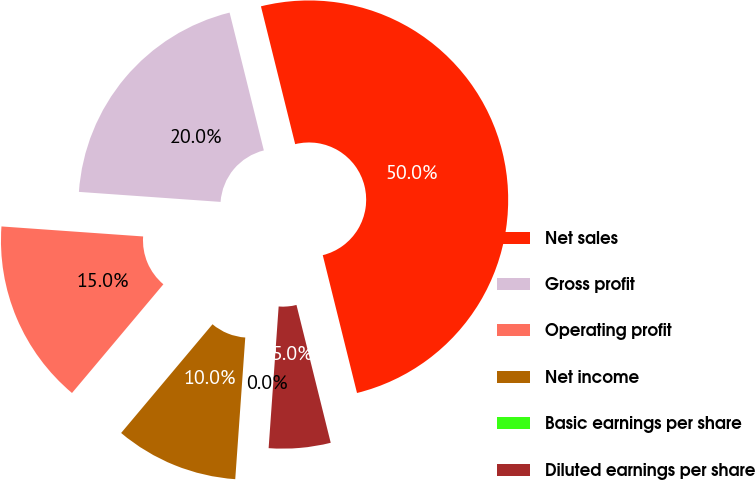Convert chart to OTSL. <chart><loc_0><loc_0><loc_500><loc_500><pie_chart><fcel>Net sales<fcel>Gross profit<fcel>Operating profit<fcel>Net income<fcel>Basic earnings per share<fcel>Diluted earnings per share<nl><fcel>50.0%<fcel>20.0%<fcel>15.0%<fcel>10.0%<fcel>0.0%<fcel>5.0%<nl></chart> 